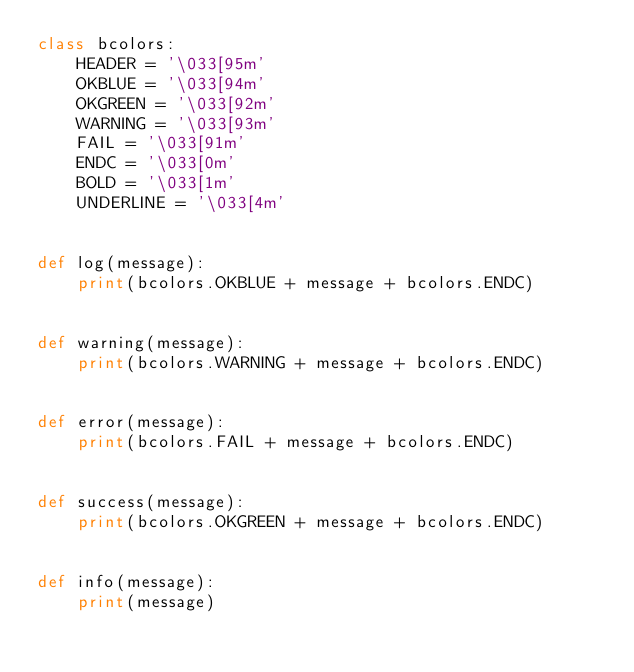<code> <loc_0><loc_0><loc_500><loc_500><_Python_>class bcolors:
    HEADER = '\033[95m'
    OKBLUE = '\033[94m'
    OKGREEN = '\033[92m'
    WARNING = '\033[93m'
    FAIL = '\033[91m'
    ENDC = '\033[0m'
    BOLD = '\033[1m'
    UNDERLINE = '\033[4m'


def log(message):
    print(bcolors.OKBLUE + message + bcolors.ENDC)


def warning(message):
    print(bcolors.WARNING + message + bcolors.ENDC)


def error(message):
    print(bcolors.FAIL + message + bcolors.ENDC)


def success(message):
    print(bcolors.OKGREEN + message + bcolors.ENDC)


def info(message):
    print(message)
</code> 